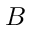Convert formula to latex. <formula><loc_0><loc_0><loc_500><loc_500>B</formula> 